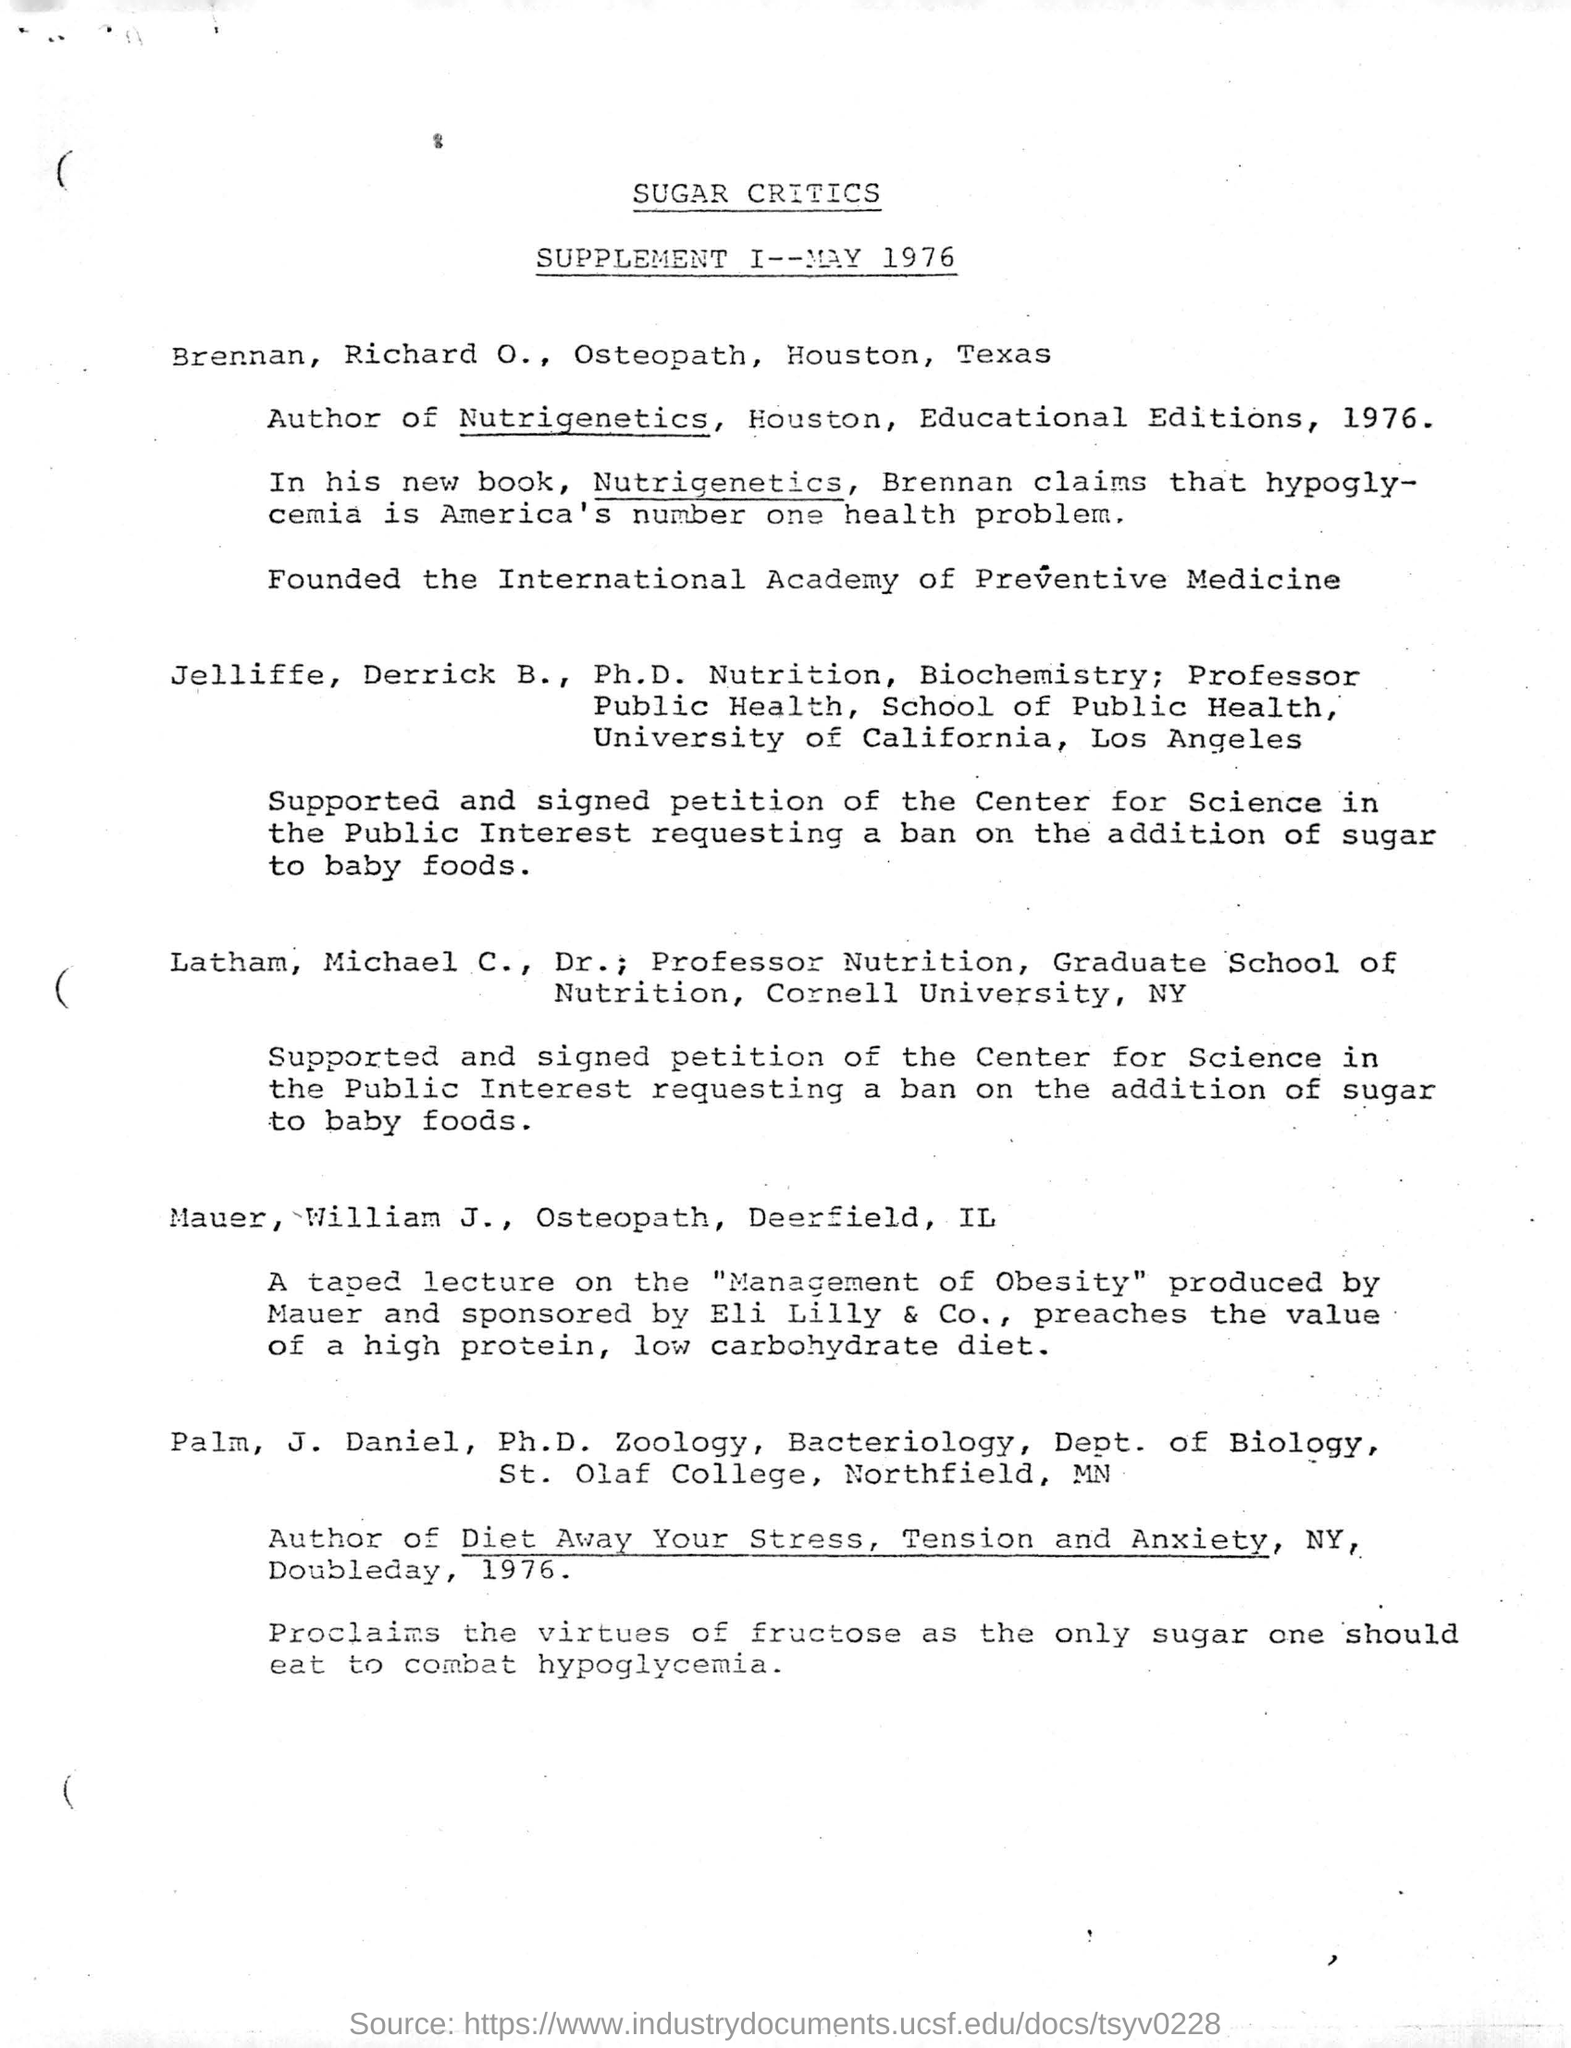Heading of the document
Offer a terse response. SUGAR CRITICS. Who claims that hypoglycemia is america's number one health problem
Give a very brief answer. Brennan. A taped lecture on what was produced by Mauer
Your answer should be very brief. Management of Obesity. Who founded the International Academy of Preventive medicine?
Your answer should be compact. Brennan, Richard O., Osteopath. 